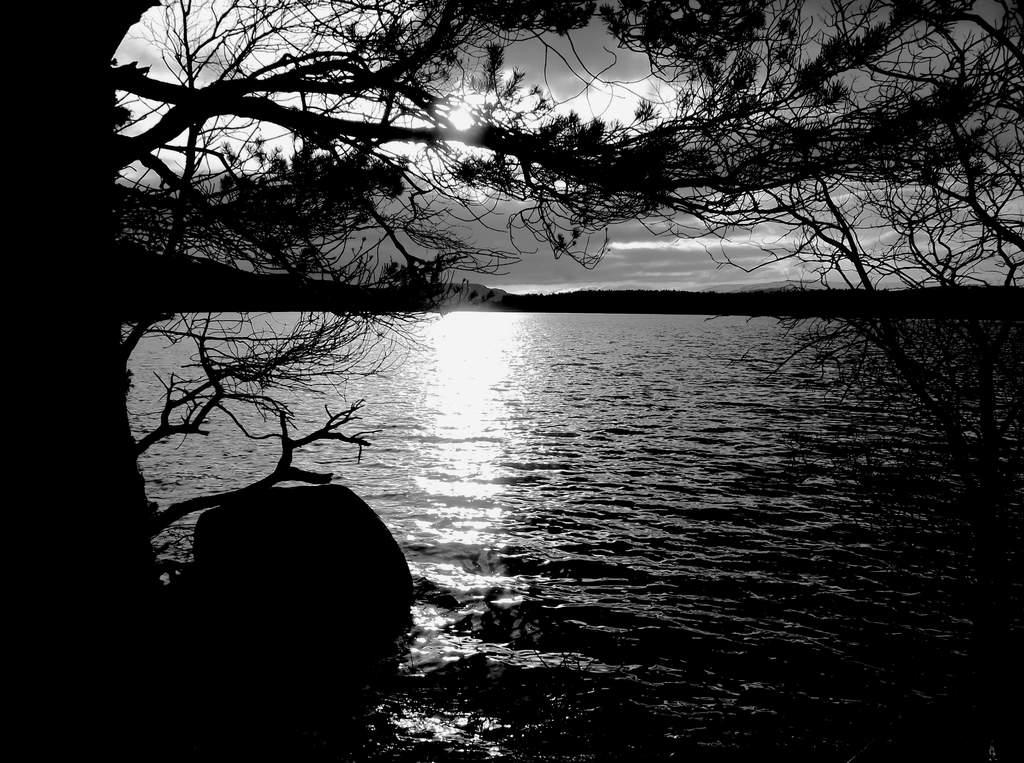What is the primary element that is flowing in the image? There is water flowing in the image. What type of vegetation can be seen in the image? There are trees with branches and leaves in the image. What is the stationary object in the image? There is a rock in the image. What is visible above the trees and water? The sky is visible in the image. What can be observed in the sky? Clouds are present in the sky. What type of beef is being served on the rock in the image? There is no beef present in the image; it features water, trees, a rock, and the sky. How does the tramp contribute to the image? There is no tramp present in the image; it is a natural scene with water, trees, a rock, and the sky. 